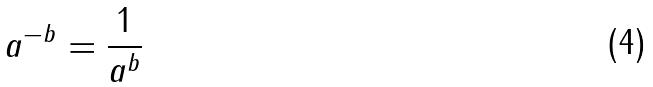Convert formula to latex. <formula><loc_0><loc_0><loc_500><loc_500>a ^ { - b } = \frac { 1 } { a ^ { b } }</formula> 